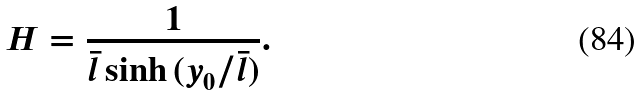<formula> <loc_0><loc_0><loc_500><loc_500>H = \frac { 1 } { \bar { l } \sinh { ( y _ { 0 } / \bar { l } ) } } .</formula> 